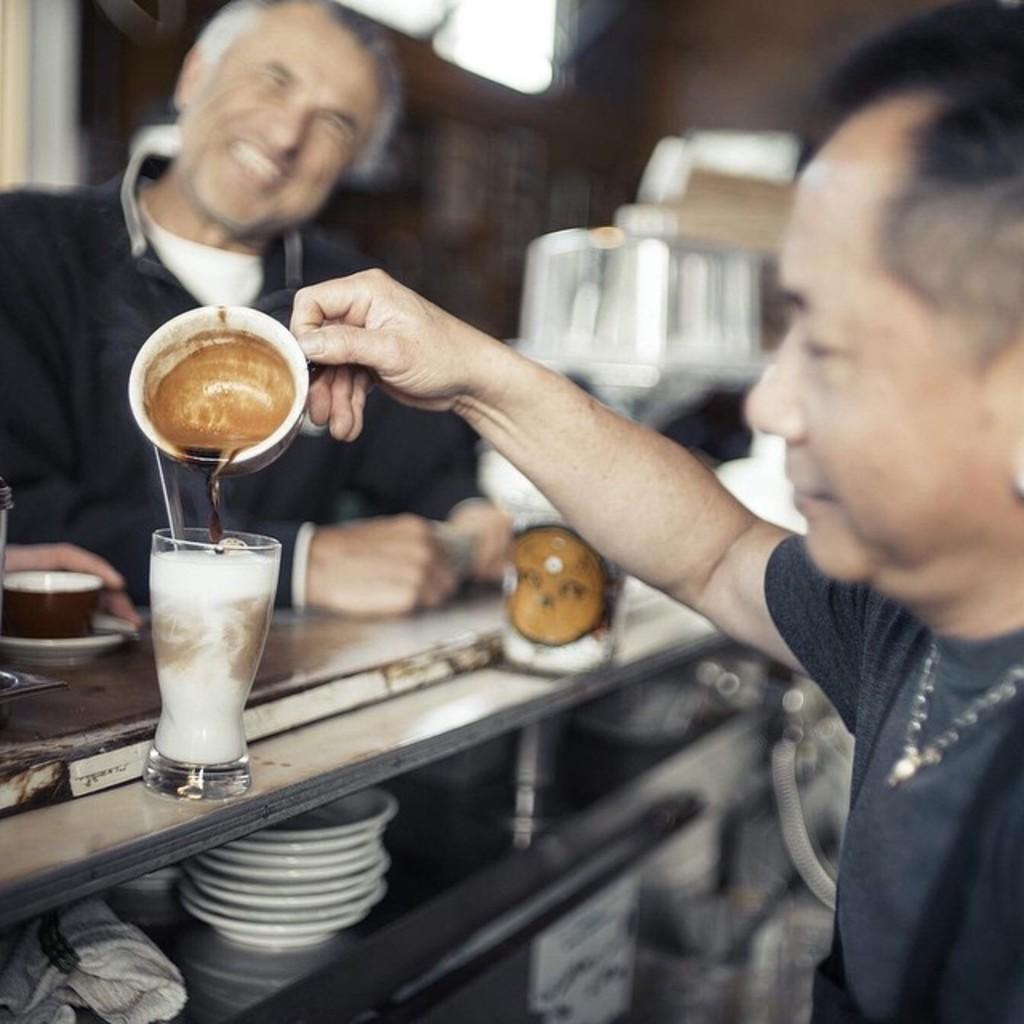Could you give a brief overview of what you see in this image? In the image we can see two men wearing clothes, they are smiling. This is a neck chain, glass, tea cup, saucer and many other things. The background is blurred. 